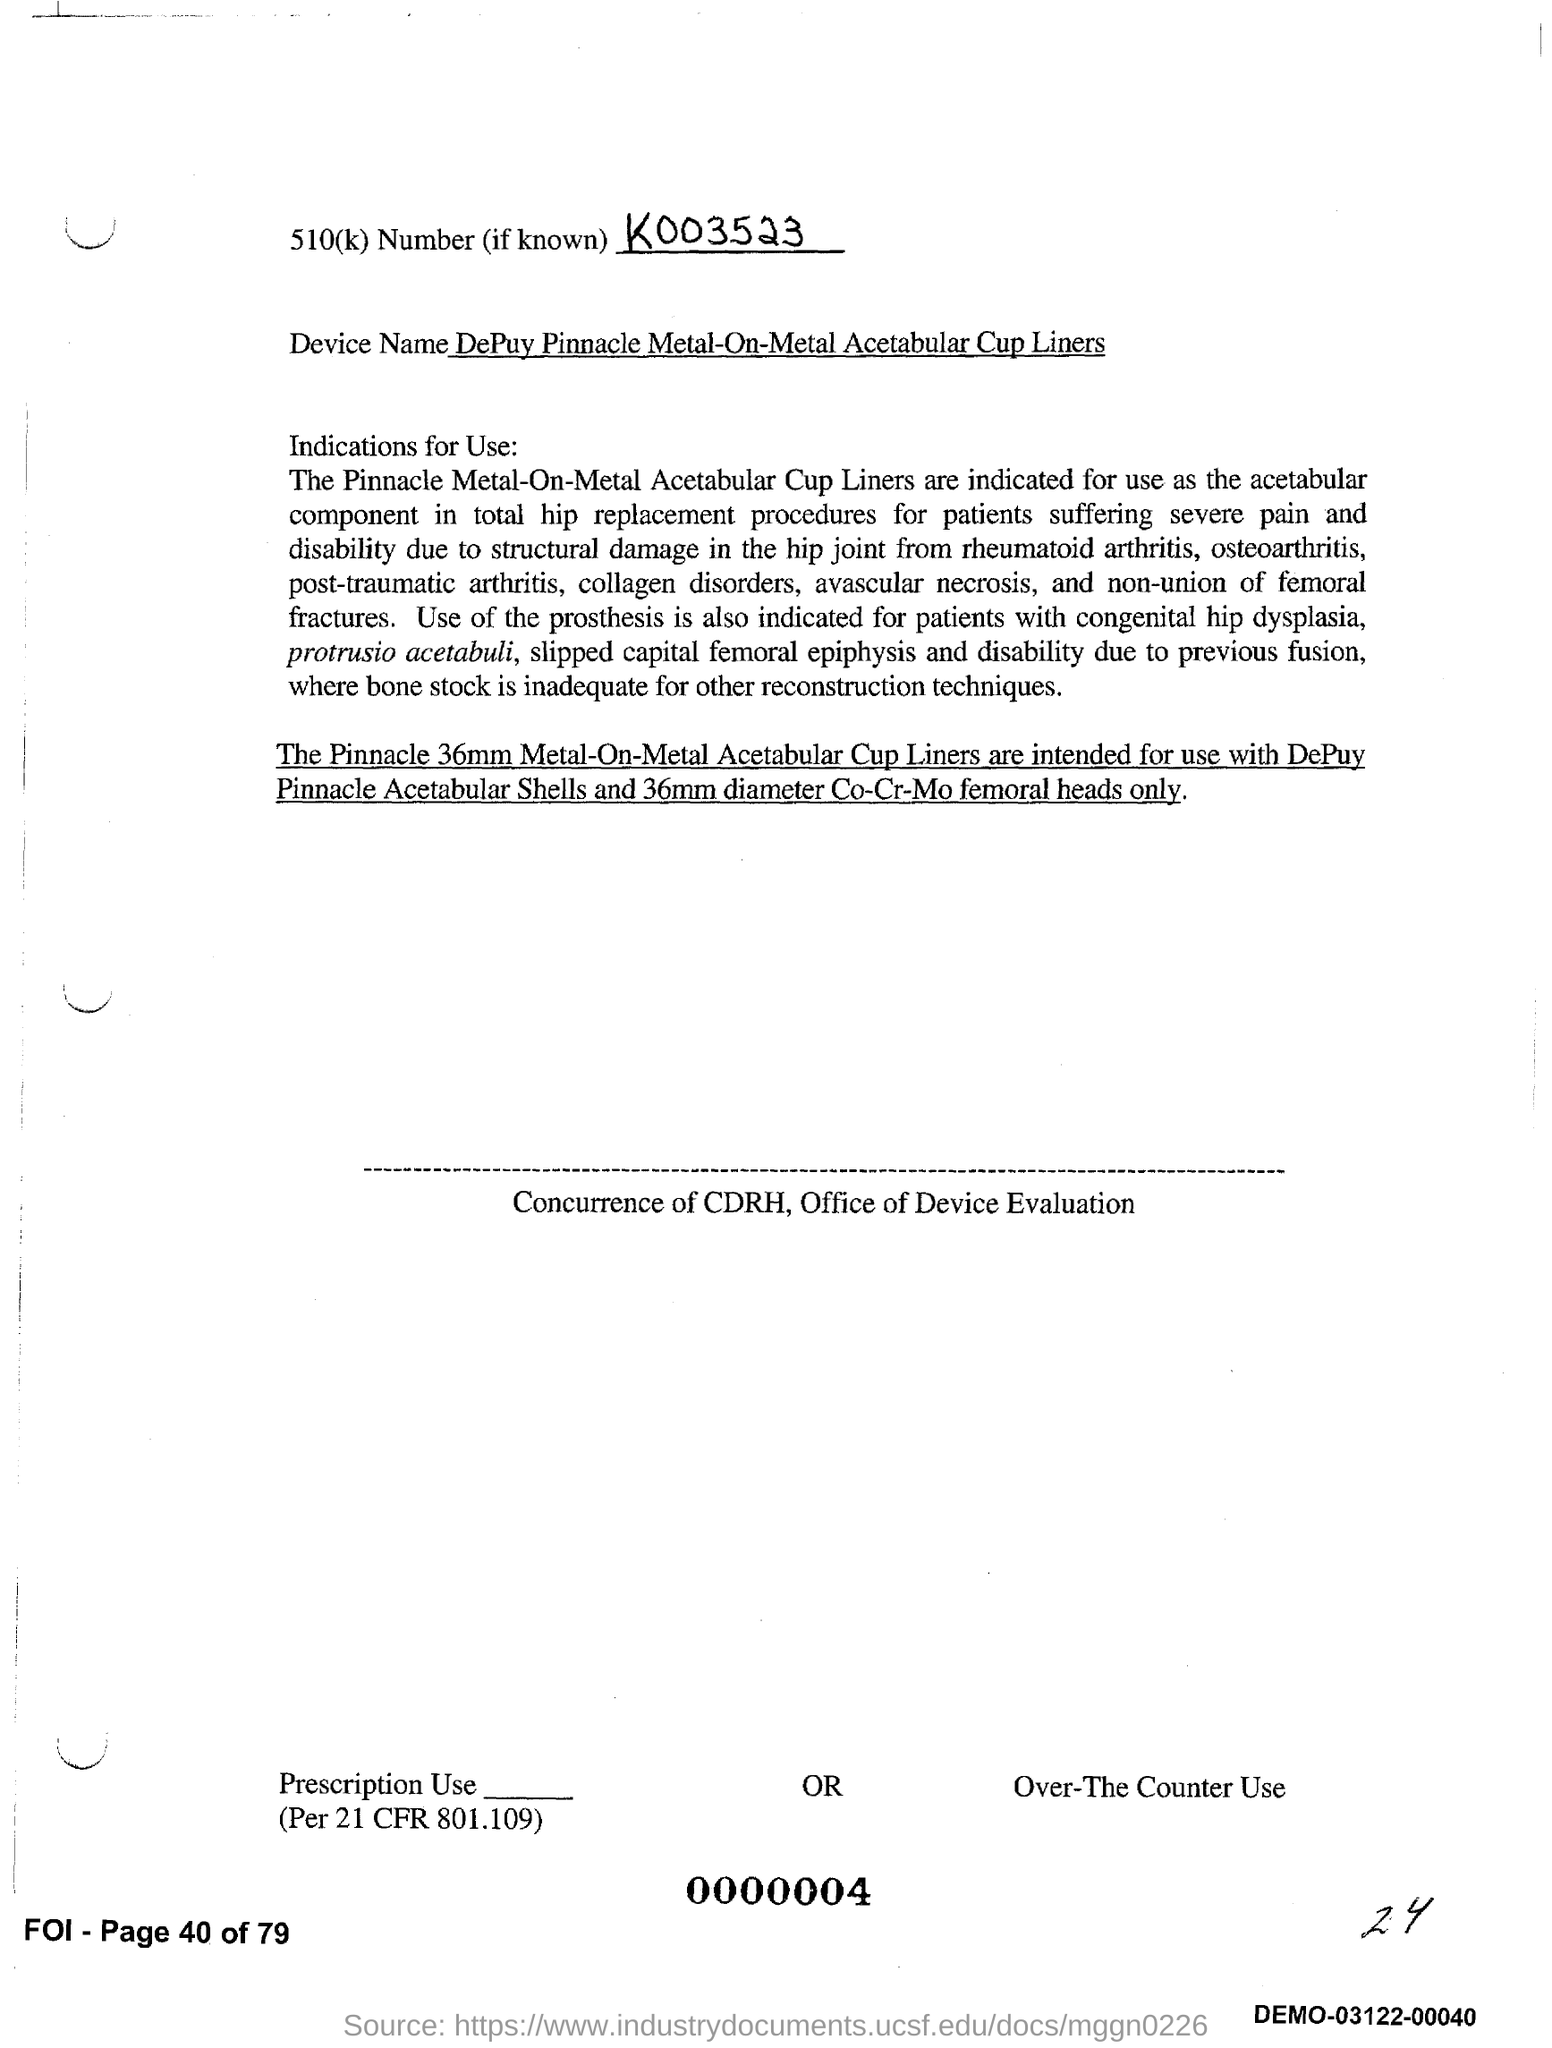Specify some key components in this picture. The device in question is a DePuy Pinnacle Metal-On-Metal Acetabular Cup Liner. The 510(k) number is K003523.. 